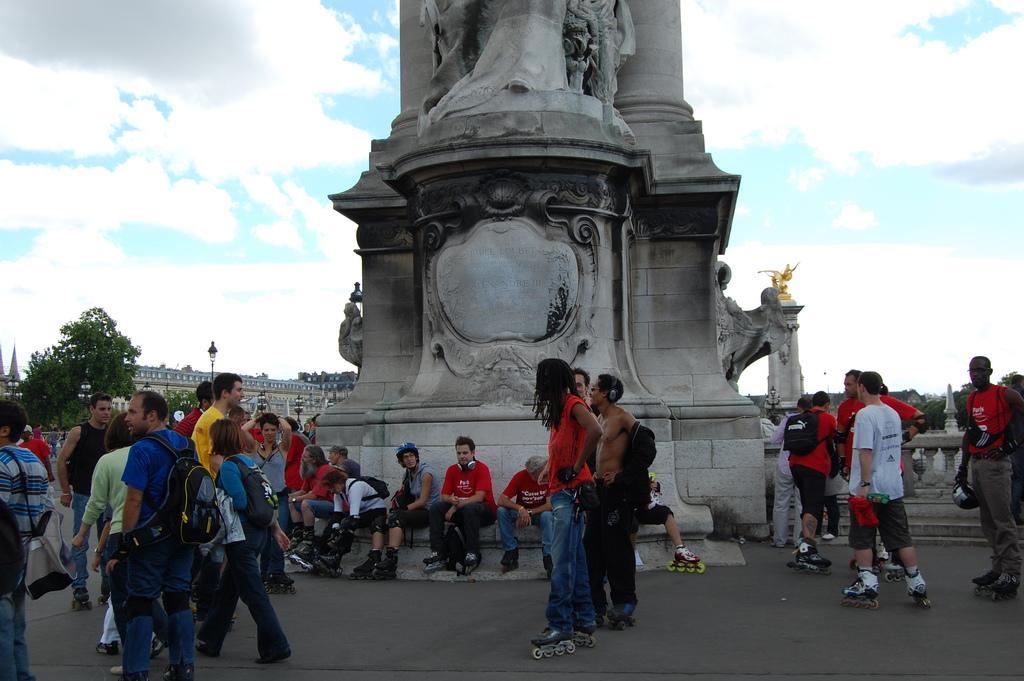Please provide a concise description of this image. In this image people are gathered near the statue, which is at the middle and background is the sky. 